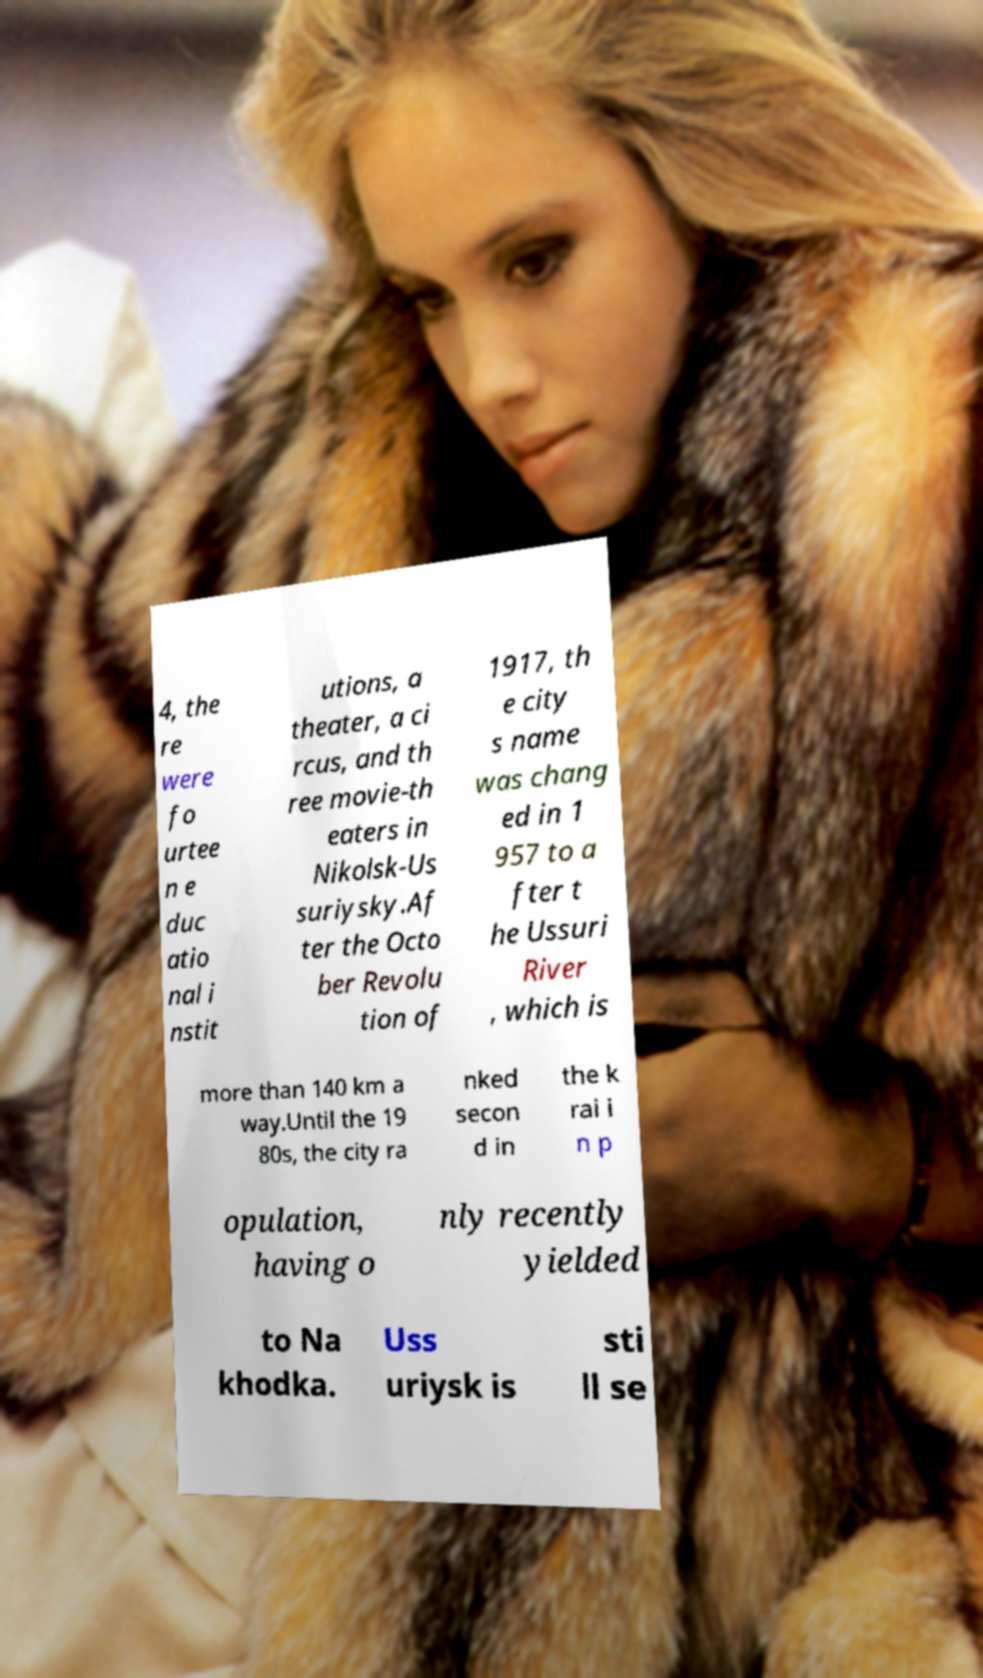What messages or text are displayed in this image? I need them in a readable, typed format. 4, the re were fo urtee n e duc atio nal i nstit utions, a theater, a ci rcus, and th ree movie-th eaters in Nikolsk-Us suriysky.Af ter the Octo ber Revolu tion of 1917, th e city s name was chang ed in 1 957 to a fter t he Ussuri River , which is more than 140 km a way.Until the 19 80s, the city ra nked secon d in the k rai i n p opulation, having o nly recently yielded to Na khodka. Uss uriysk is sti ll se 